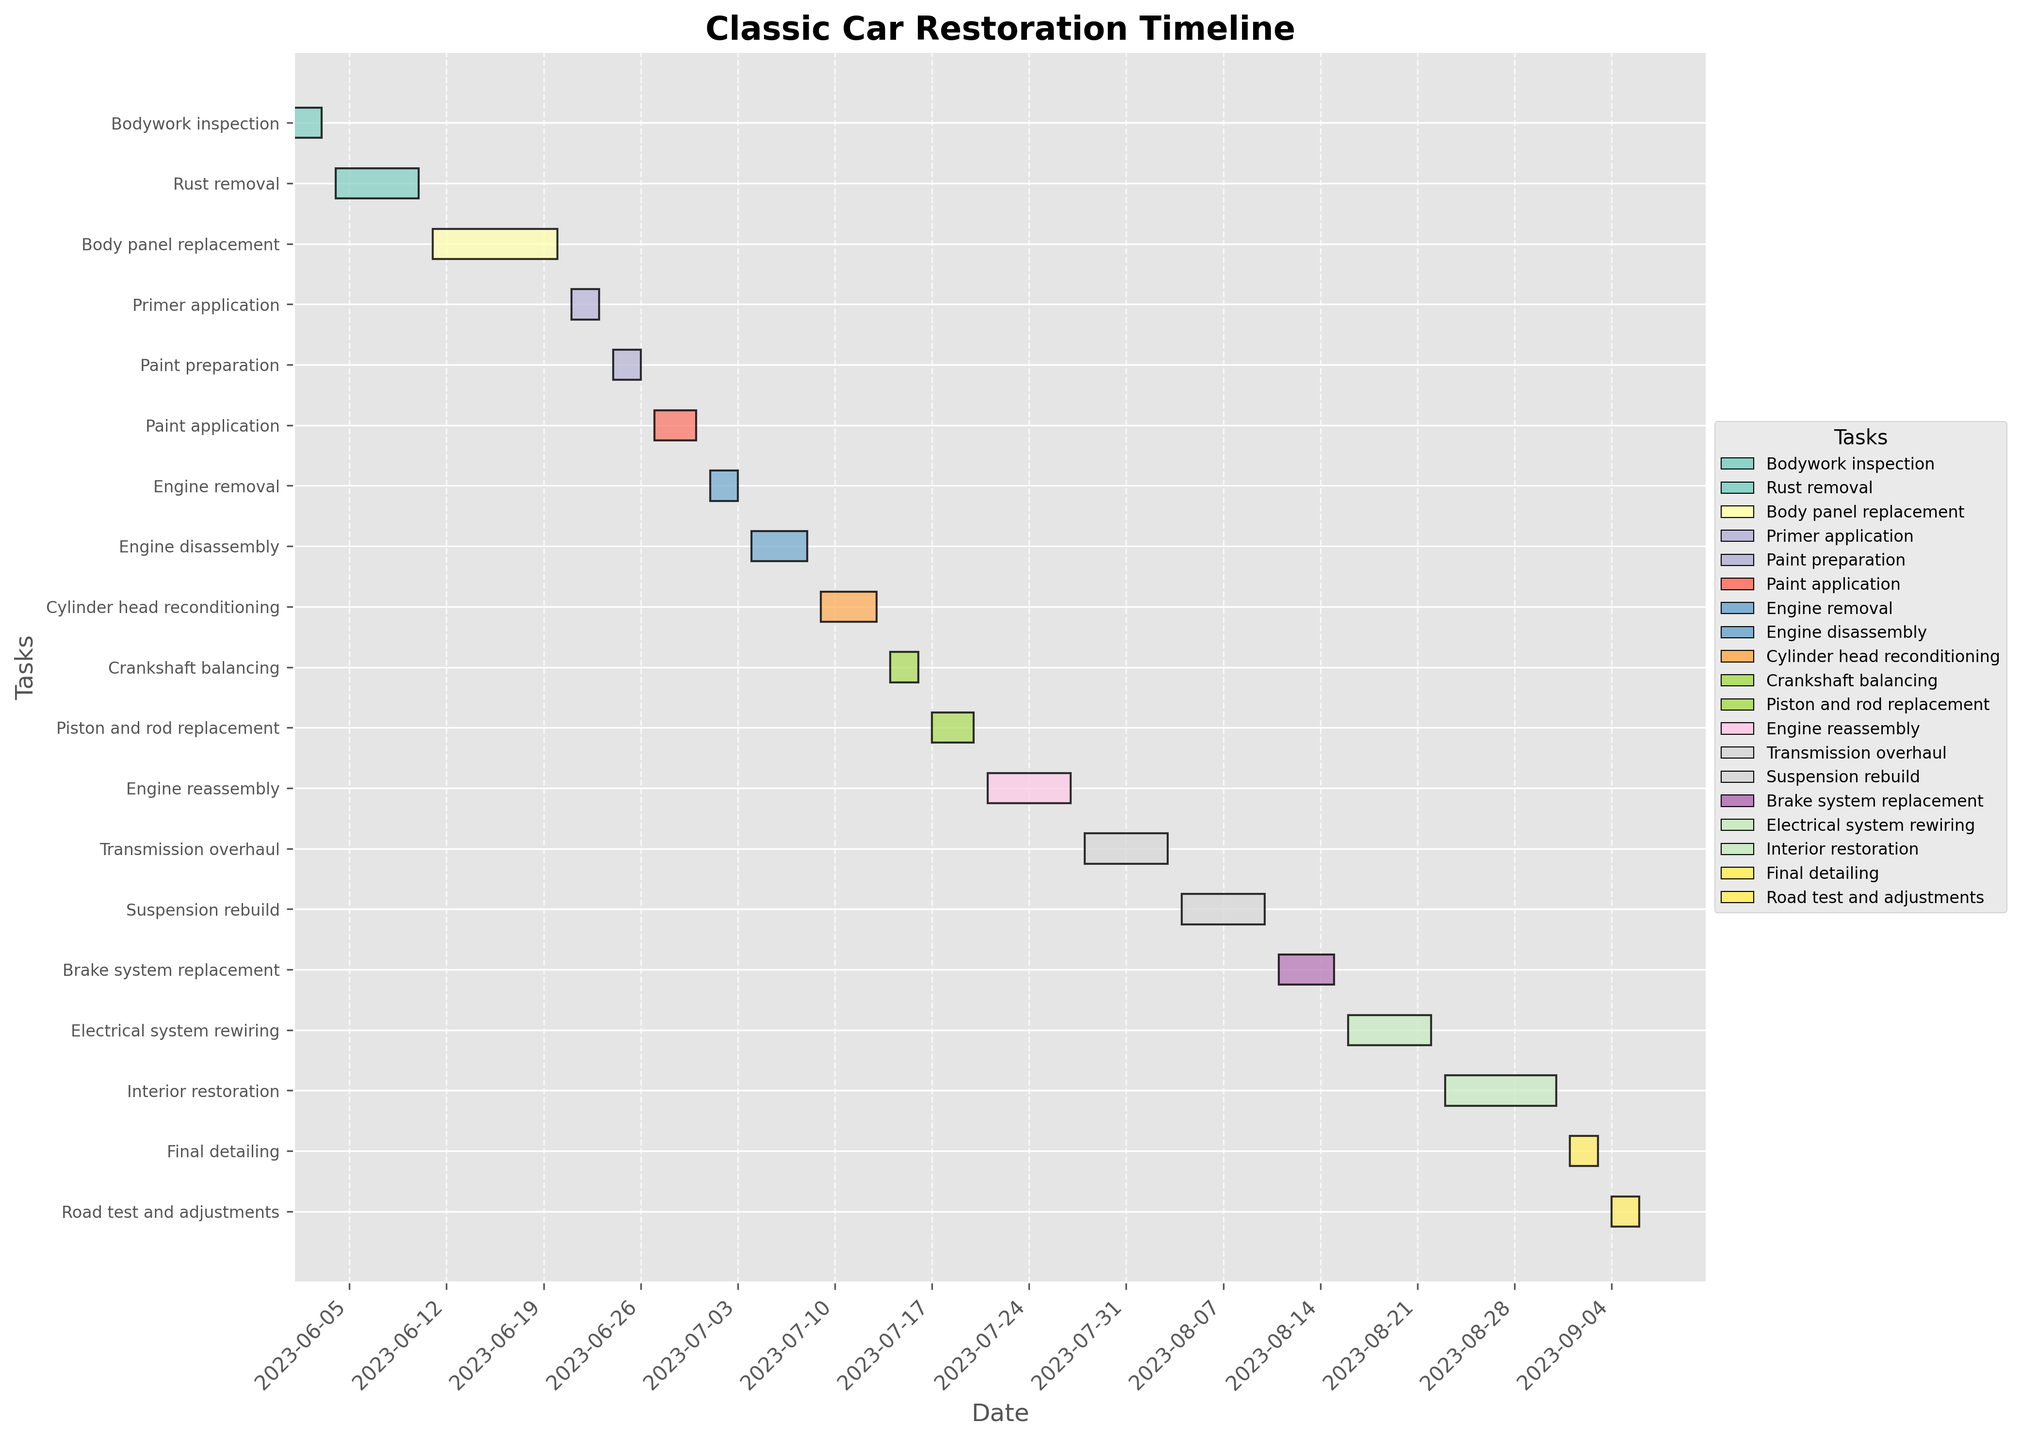What is the duration of the "Rust removal" task? The duration of the "Rust removal" task can be deduced by looking at the bar length and reading the number of days planned for this task in the chart. The task spans from June 4, 2023, to June 10, 2023, which totals 7 days.
Answer: 7 days Which task takes the longest time to complete? To find the task that takes the longest time, we need to identify the task with the longest bar in the Gantt chart. "Interior restoration" spans from August 23, 2023, to August 31, 2023, which is 9 days—the longest duration among the tasks.
Answer: Interior restoration How many tasks are scheduled for completion in August? To count the number of tasks scheduled in August, we look at the Gantt chart and identify the bars that either start or end in August. The tasks are "Transmission overhaul," "Suspension rebuild," "Brake system replacement," "Electrical system rewiring," "Interior restoration," "Final detailing," and "Road test and adjustments." There are 7 tasks in total.
Answer: 7 Which tasks are taking place concurrently on August 3, 2023? To determine which tasks are happening concurrently on August 3, 2023, we check the bars that span this date. "Engine reassembly" (July 21, 2023, to July 27, 2023) and "Transmission overhaul" (July 28, 2023, to August 3, 2023) overlap on this day. Therefore, "Transmission overhaul" is the task occurring on August 3, 2023.
Answer: Transmission overhaul What are the start and end dates for the "Paint application" task? By referring to the Gantt chart, the "Paint application" task's start and end dates can be identified as June 27, 2023, to June 30, 2023.
Answer: June 27, 2023, to June 30, 2023 Are there more tasks scheduled in July or August? To compare the number of scheduled tasks in July and August, we count the bars that either start or end within each month. July has "Engine removal," "Engine disassembly," "Cylinder head reconditioning," "Crankshaft balancing," "Piston and rod replacement," "Engine reassembly," and "Transmission overhaul," totaling 7 tasks. August has "Transmission overhaul," "Suspension rebuild," "Brake system replacement," "Electrical system rewiring," "Interior restoration," "Final detailing," and "Road test and adjustments," totaling 7 tasks. Both months have the same number of scheduled tasks, which is 7.
Answer: Both months have equal tasks What tasks follow immediately after "Rust removal"? To find the task that follows "Rust removal," we check the end date of "Rust removal" on June 10, 2023, and identify the next task. "Body panel replacement" starts immediately after on June 11, 2023.
Answer: Body panel replacement Which task begins last in the whole restoration schedule? To determine the last task to begin in the schedule, we look at the start dates. The "Road test and adjustments" task begins last on September 4, 2023.
Answer: Road test and adjustments What is the total duration from the start of the first task to the end of the last task? To calculate the total duration, we find the start date of the first task and the end date of the last task. "Bodywork inspection" starts on June 1, 2023, and "Road test and adjustments" ends on September 6, 2023. The total duration is from June 1, 2023, to September 6, 2023, which is 98 days.
Answer: 98 days 